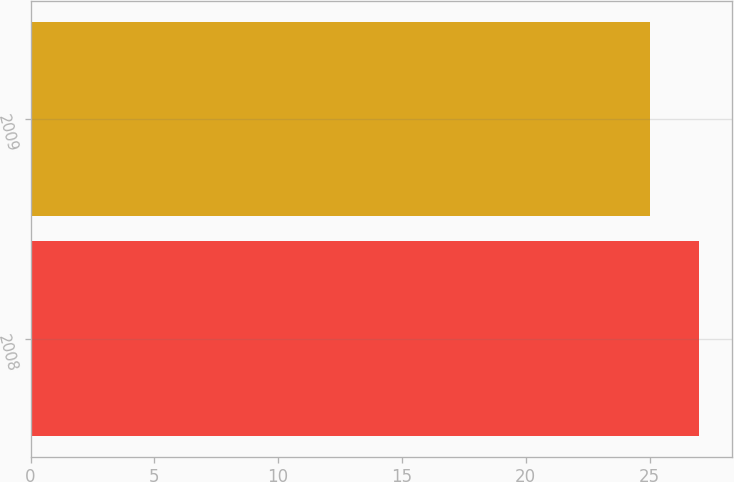Convert chart to OTSL. <chart><loc_0><loc_0><loc_500><loc_500><bar_chart><fcel>2008<fcel>2009<nl><fcel>27<fcel>25<nl></chart> 